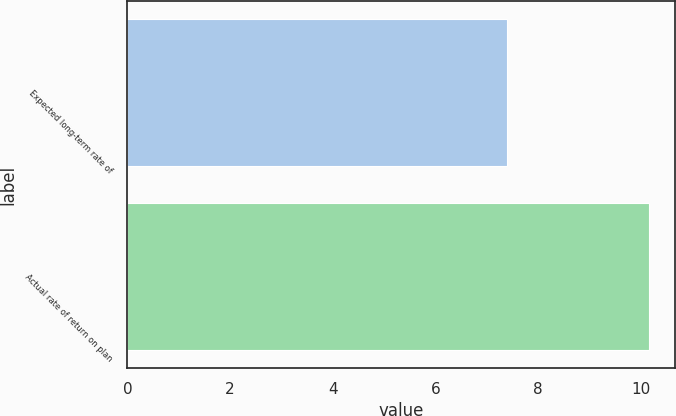Convert chart. <chart><loc_0><loc_0><loc_500><loc_500><bar_chart><fcel>Expected long-term rate of<fcel>Actual rate of return on plan<nl><fcel>7.4<fcel>10.17<nl></chart> 